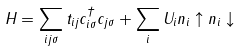<formula> <loc_0><loc_0><loc_500><loc_500>H = \sum _ { i j \sigma } t _ { i j } c _ { i \sigma } ^ { \dag } c _ { j \sigma } + \sum _ { i } U _ { i } n _ { i } \uparrow n _ { i } \downarrow</formula> 